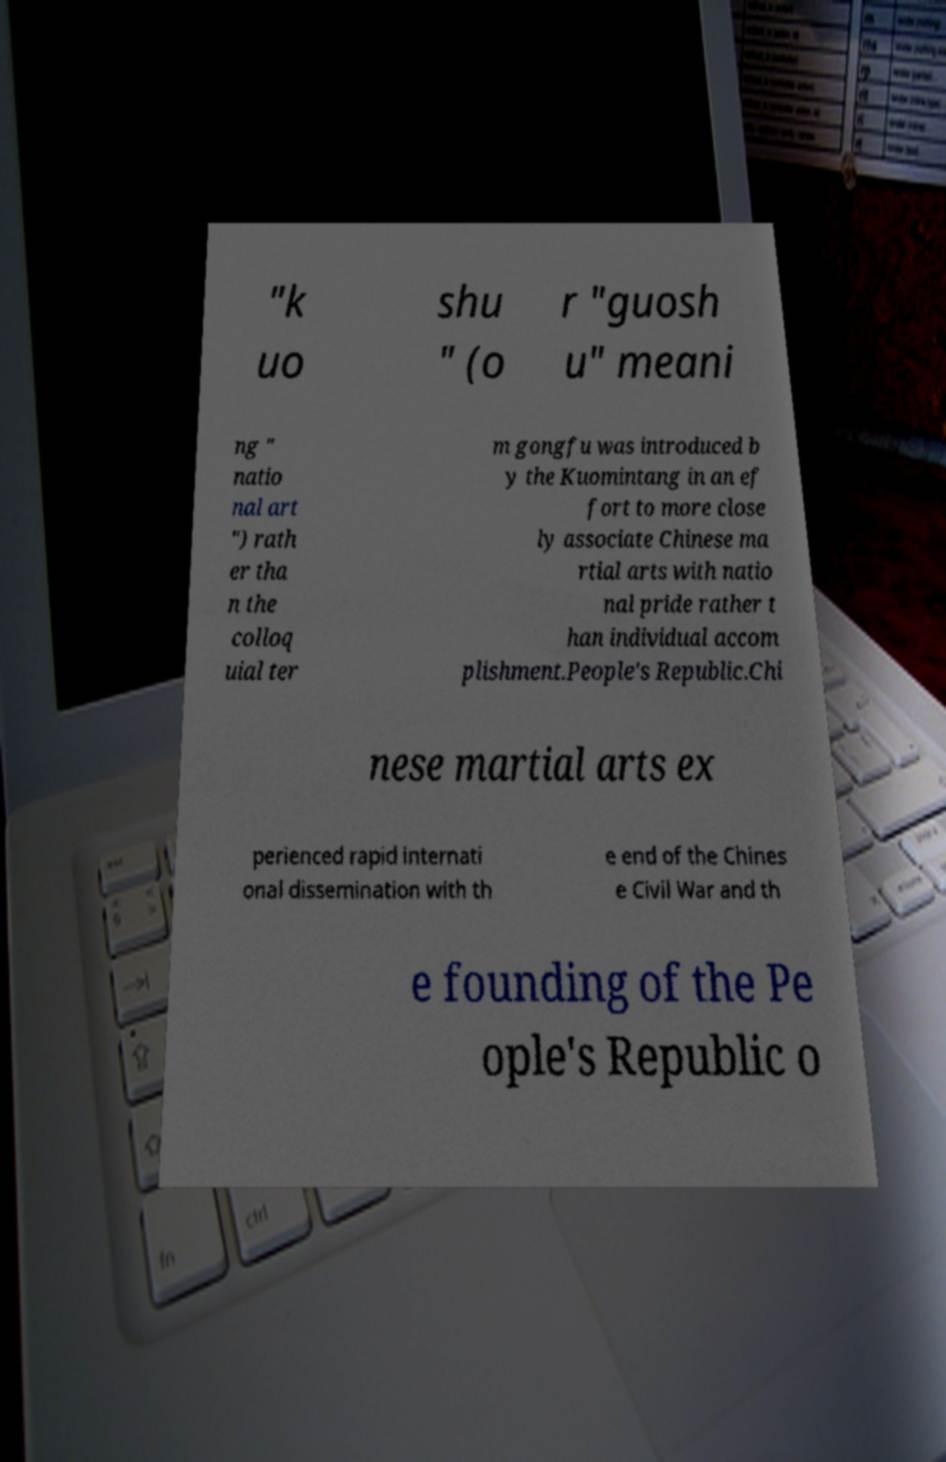There's text embedded in this image that I need extracted. Can you transcribe it verbatim? "k uo shu " (o r "guosh u" meani ng " natio nal art ") rath er tha n the colloq uial ter m gongfu was introduced b y the Kuomintang in an ef fort to more close ly associate Chinese ma rtial arts with natio nal pride rather t han individual accom plishment.People's Republic.Chi nese martial arts ex perienced rapid internati onal dissemination with th e end of the Chines e Civil War and th e founding of the Pe ople's Republic o 